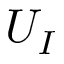Convert formula to latex. <formula><loc_0><loc_0><loc_500><loc_500>U _ { I }</formula> 